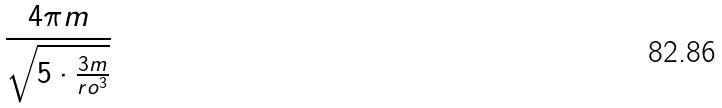<formula> <loc_0><loc_0><loc_500><loc_500>\frac { 4 \pi m } { \sqrt { 5 \cdot \frac { 3 m } { r o ^ { 3 } } } }</formula> 